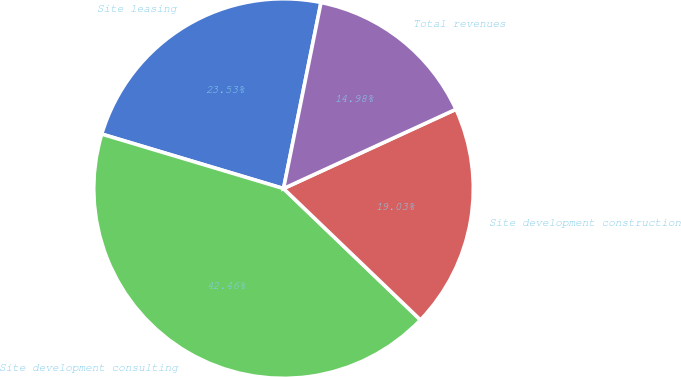Convert chart. <chart><loc_0><loc_0><loc_500><loc_500><pie_chart><fcel>Site leasing<fcel>Site development consulting<fcel>Site development construction<fcel>Total revenues<nl><fcel>23.53%<fcel>42.46%<fcel>19.03%<fcel>14.98%<nl></chart> 